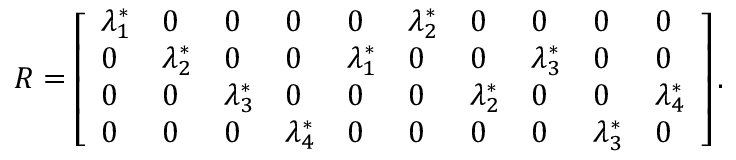<formula> <loc_0><loc_0><loc_500><loc_500>\begin{array} { r } { R = \left [ \begin{array} { l l l l l l l l l l } { \lambda _ { 1 } ^ { * } } & { 0 } & { 0 } & { 0 } & { 0 } & { \lambda _ { 2 } ^ { * } } & { 0 } & { 0 } & { 0 } & { 0 } \\ { 0 } & { \lambda _ { 2 } ^ { * } } & { 0 } & { 0 } & { \lambda _ { 1 } ^ { * } } & { 0 } & { 0 } & { \lambda _ { 3 } ^ { * } } & { 0 } & { 0 } \\ { 0 } & { 0 } & { \lambda _ { 3 } ^ { * } } & { 0 } & { 0 } & { 0 } & { \lambda _ { 2 } ^ { * } } & { 0 } & { 0 } & { \lambda _ { 4 } ^ { * } } \\ { 0 } & { 0 } & { 0 } & { \lambda _ { 4 } ^ { * } } & { 0 } & { 0 } & { 0 } & { 0 } & { \lambda _ { 3 } ^ { * } } & { 0 } \end{array} \right ] . } \end{array}</formula> 